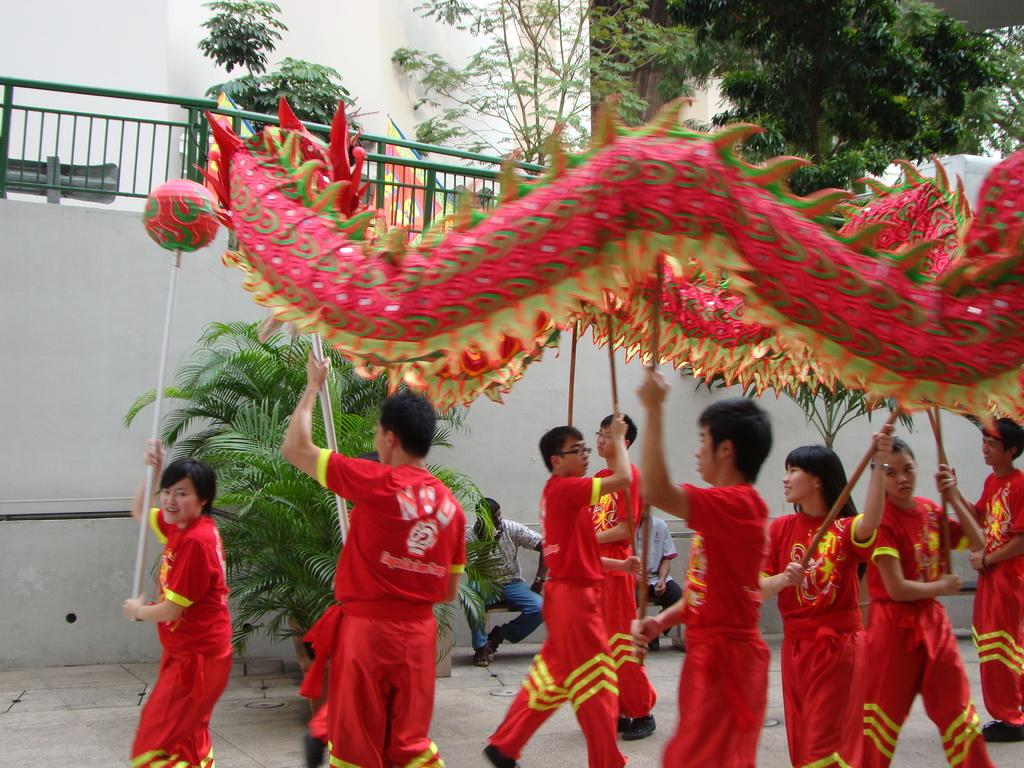What are the people holding in the image? The facts do not specify what objects the people are holding. What can be seen under the people's feet in the image? The floor is visible in the image. What surrounds the area where the people are standing in the image? The walls are visible in the image. What type of vegetation is present in the image? There is a plant and trees in the image. What architectural feature can be seen in the image? There is a railing in the image. Where are the two persons sitting in the image? The two persons are sitting on a bench in the image. What type of cracker is being used as a spy device in the image? There is no mention of a cracker or any spy device in the image. What animals can be seen in the zoo depicted in the image? There is no zoo present in the image. 